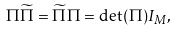<formula> <loc_0><loc_0><loc_500><loc_500>\Pi \widetilde { \Pi } = \widetilde { \Pi } \Pi = \det ( \Pi ) I _ { M } ,</formula> 